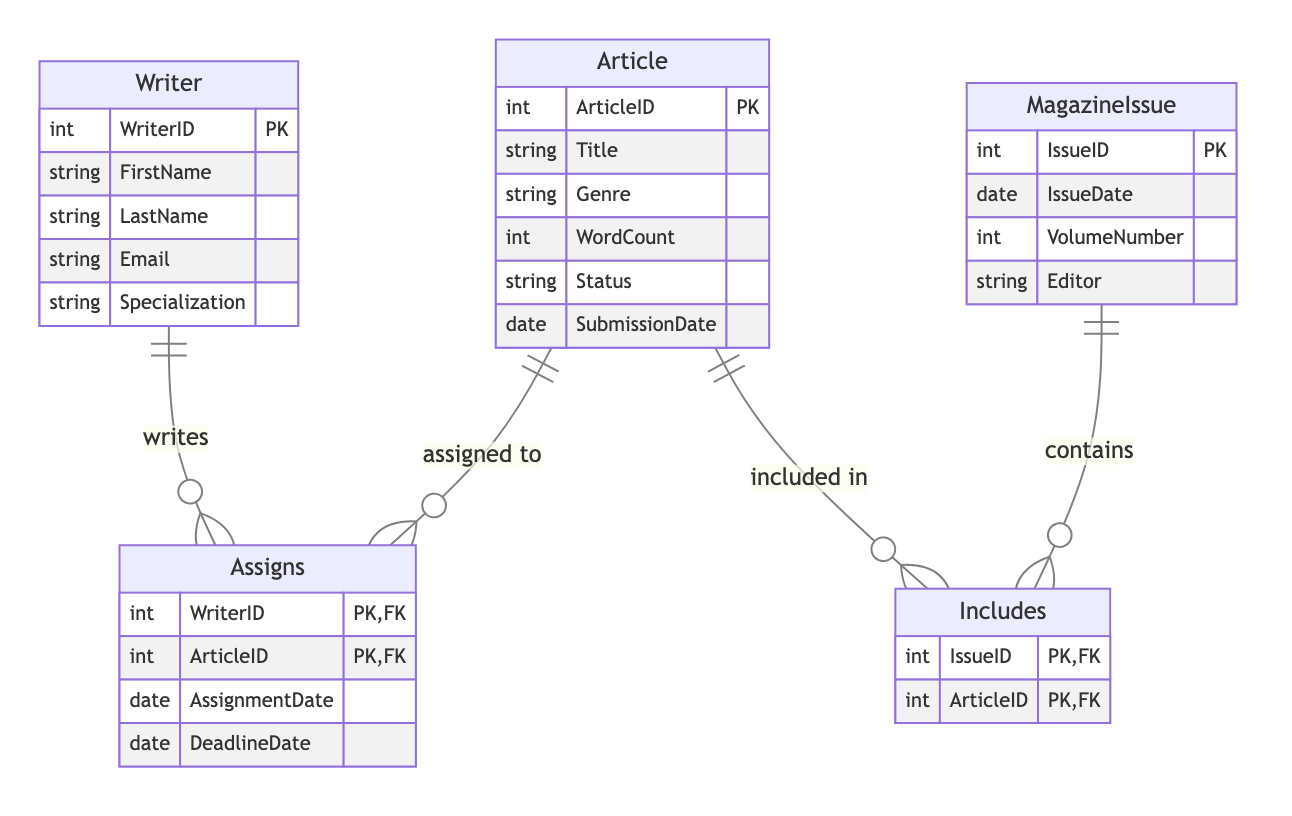What is the primary key of the Writer entity? The diagram specifies that the Writer entity includes an attribute marked as the primary key, which is WriterID.
Answer: WriterID How many attributes does the Article entity have? By counting the listed attributes inside the Article entity in the diagram, we find it has six attributes: ArticleID, Title, Genre, WordCount, Status, and SubmissionDate.
Answer: Six What relationship connects Writer to Article? The diagram shows the relationship is called "Assigns", which links the Writer and Article entities.
Answer: Assigns What are the primary keys of the Assigns relationship? The primary keys for the Assigns relationship are specified as WriterID and ArticleID in the diagram.
Answer: WriterID, ArticleID What does the Includes relationship signify? The Includes relationship indicates a connection between the MagazineIssue and Article entities, showing that a magazine issue contains articles.
Answer: Contains Which entity has the attribute titled 'VolumeNumber'? The VolumeNumber attribute is listed under the MagazineIssue entity in the diagram, indicating it belongs to that entity.
Answer: MagazineIssue How many entities are depicted in this diagram? The diagram lists three distinct entities: Writer, Article, and MagazineIssue, indicating a total of three entities.
Answer: Three What attribute is common between the Article and MagazineIssue entities in this diagram? There is no attribute that is explicitly common to both Article and MagazineIssue entities within the entities listed in the diagram. They are distinct with their respective attributes.
Answer: None What type of relationship does Article have with MagazineIssue? Article has a relationship called "Includes" with MagazineIssue, showing that articles are included in magazine issues.
Answer: Includes 